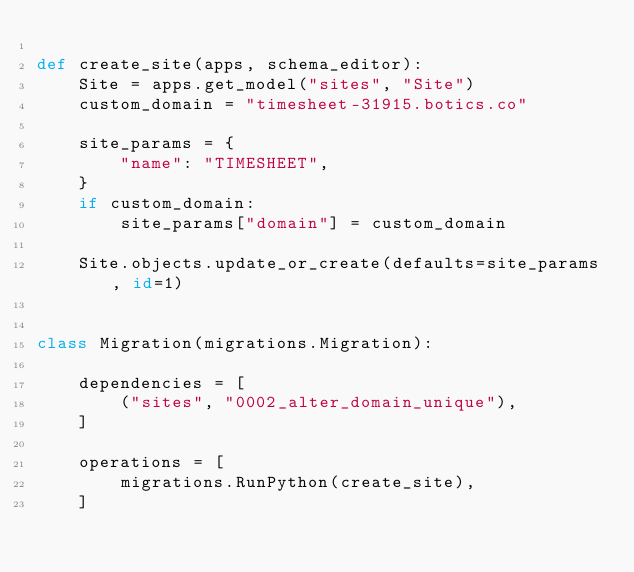<code> <loc_0><loc_0><loc_500><loc_500><_Python_>
def create_site(apps, schema_editor):
    Site = apps.get_model("sites", "Site")
    custom_domain = "timesheet-31915.botics.co"

    site_params = {
        "name": "TIMESHEET",
    }
    if custom_domain:
        site_params["domain"] = custom_domain

    Site.objects.update_or_create(defaults=site_params, id=1)


class Migration(migrations.Migration):

    dependencies = [
        ("sites", "0002_alter_domain_unique"),
    ]

    operations = [
        migrations.RunPython(create_site),
    ]
</code> 